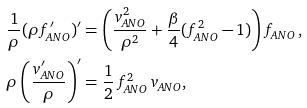<formula> <loc_0><loc_0><loc_500><loc_500>\frac { 1 } { \rho } ( \rho f _ { A N O } ^ { \prime } ) ^ { \prime } & = \left ( \frac { v ^ { 2 } _ { A N O } } { \rho ^ { 2 } } + \frac { \beta } { 4 } ( f _ { A N O } ^ { 2 } - 1 ) \right ) f _ { A N O } \, , \\ \rho \left ( \frac { v _ { A N O } ^ { \prime } } { \rho } \right ) ^ { \prime } & = \frac { 1 } { 2 } \, f _ { A N O } ^ { 2 } \, v _ { A N O } ,</formula> 